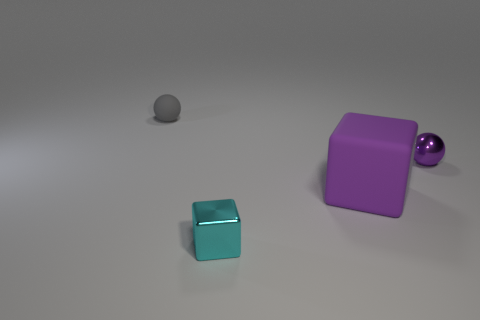Is the small matte object the same shape as the small purple metallic thing? The small matte object, which appears to be a sphere, is not the same shape as the small purple object that seems metallic and spherical. However, there is a small metallic purple cube in the image, and the small matte item mentioned does not share its cube shape. 